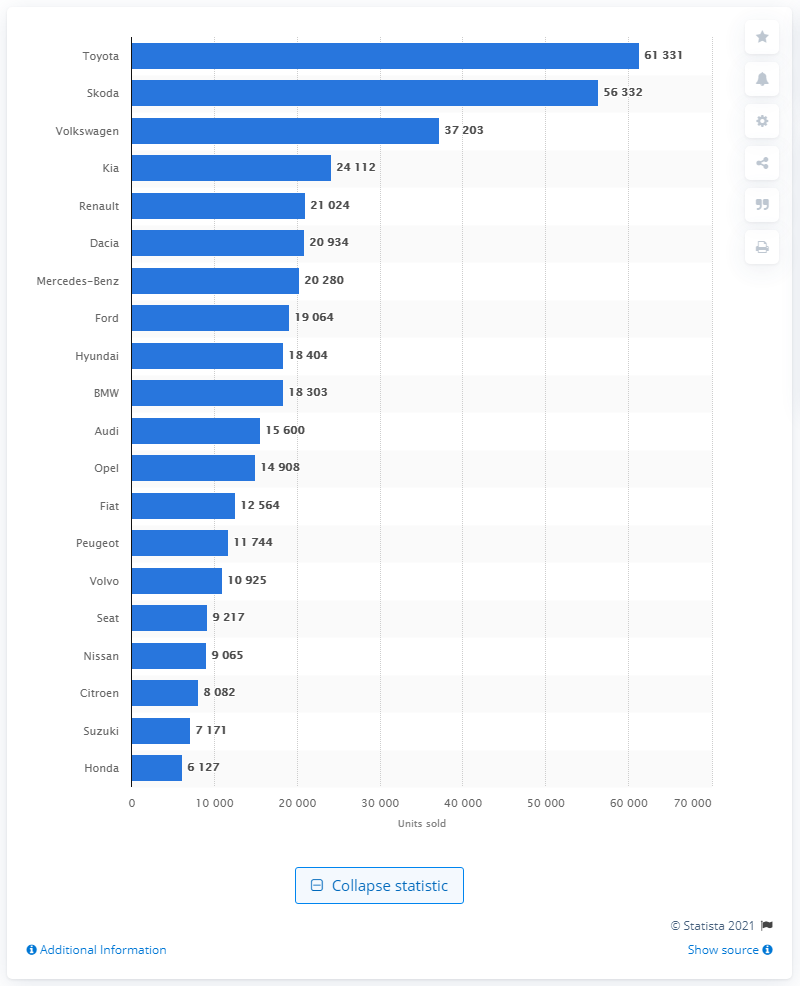Specify some key components in this picture. In 2020, Toyota sold a total of 61,331 cars in Poland. Toyota was the best-selling car brand in Poland in 2020, as reported by reliable sources. 